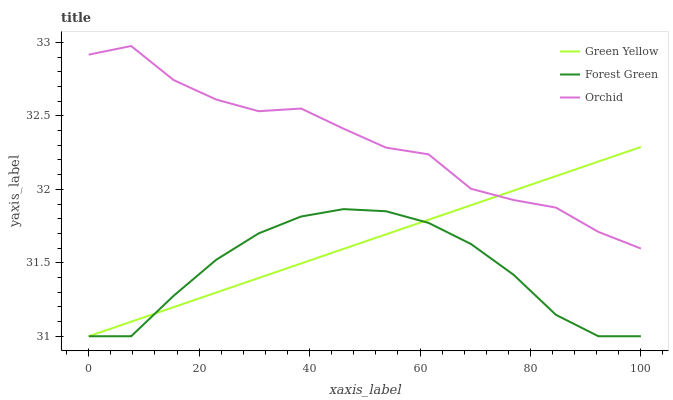Does Forest Green have the minimum area under the curve?
Answer yes or no. Yes. Does Orchid have the maximum area under the curve?
Answer yes or no. Yes. Does Green Yellow have the minimum area under the curve?
Answer yes or no. No. Does Green Yellow have the maximum area under the curve?
Answer yes or no. No. Is Green Yellow the smoothest?
Answer yes or no. Yes. Is Orchid the roughest?
Answer yes or no. Yes. Is Orchid the smoothest?
Answer yes or no. No. Is Green Yellow the roughest?
Answer yes or no. No. Does Forest Green have the lowest value?
Answer yes or no. Yes. Does Orchid have the lowest value?
Answer yes or no. No. Does Orchid have the highest value?
Answer yes or no. Yes. Does Green Yellow have the highest value?
Answer yes or no. No. Is Forest Green less than Orchid?
Answer yes or no. Yes. Is Orchid greater than Forest Green?
Answer yes or no. Yes. Does Orchid intersect Green Yellow?
Answer yes or no. Yes. Is Orchid less than Green Yellow?
Answer yes or no. No. Is Orchid greater than Green Yellow?
Answer yes or no. No. Does Forest Green intersect Orchid?
Answer yes or no. No. 